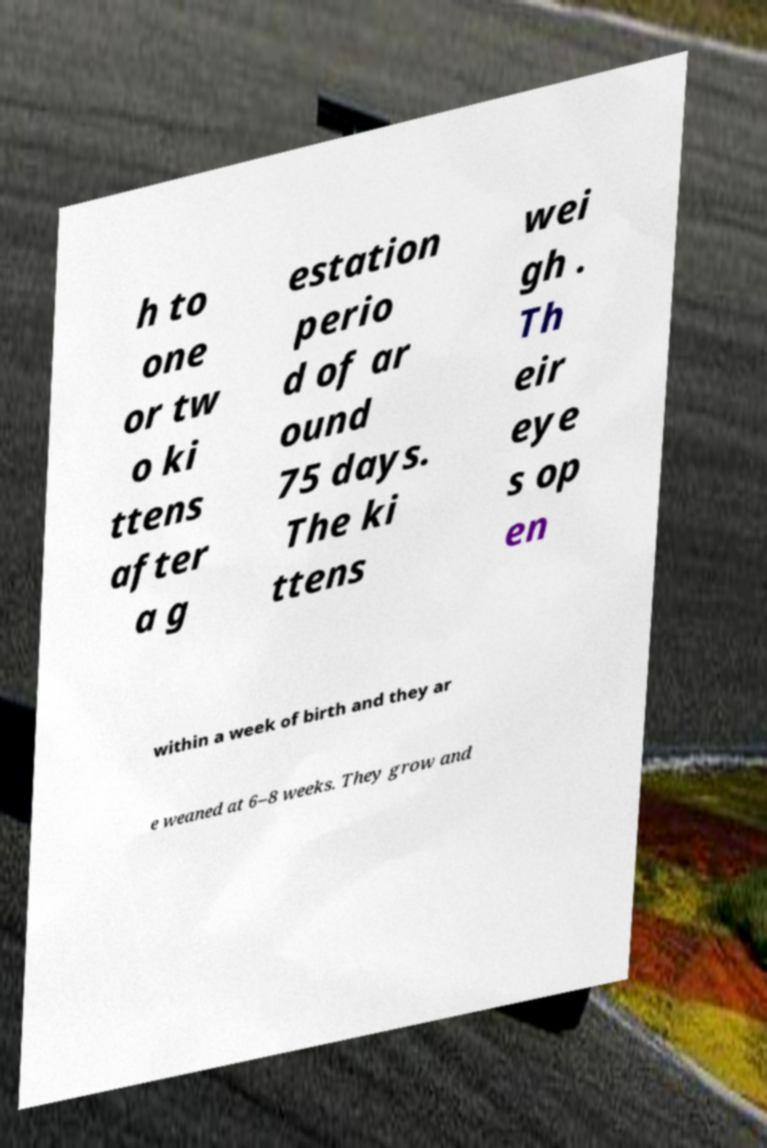What messages or text are displayed in this image? I need them in a readable, typed format. h to one or tw o ki ttens after a g estation perio d of ar ound 75 days. The ki ttens wei gh . Th eir eye s op en within a week of birth and they ar e weaned at 6–8 weeks. They grow and 